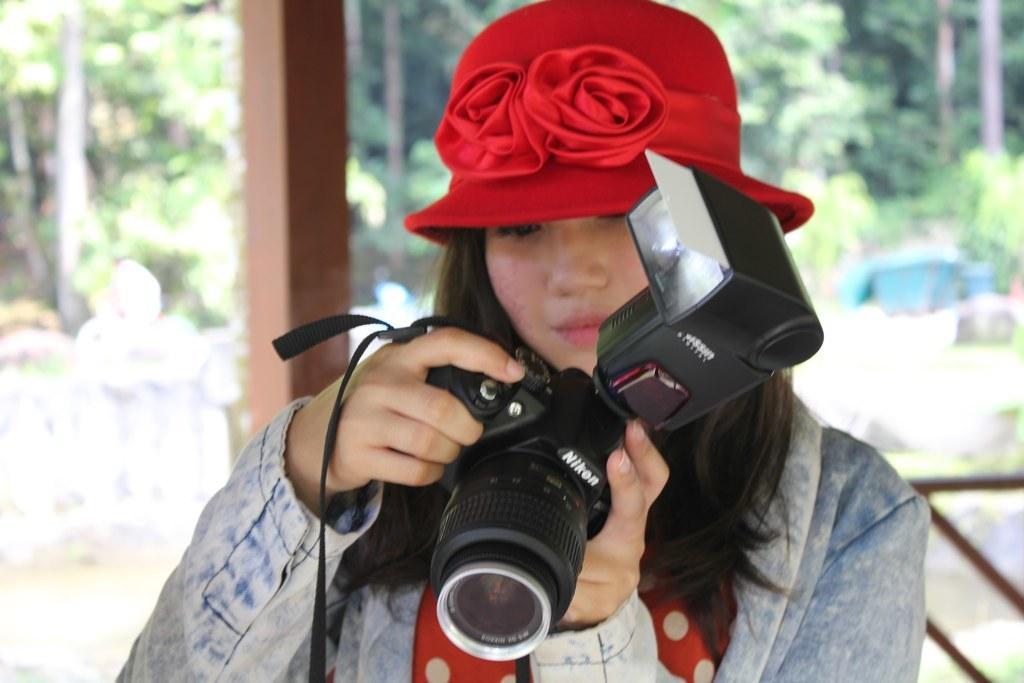In one or two sentences, can you explain what this image depicts? In this picture we can see a woman who is holding a camera with her hands. On the background we can see some trees. 